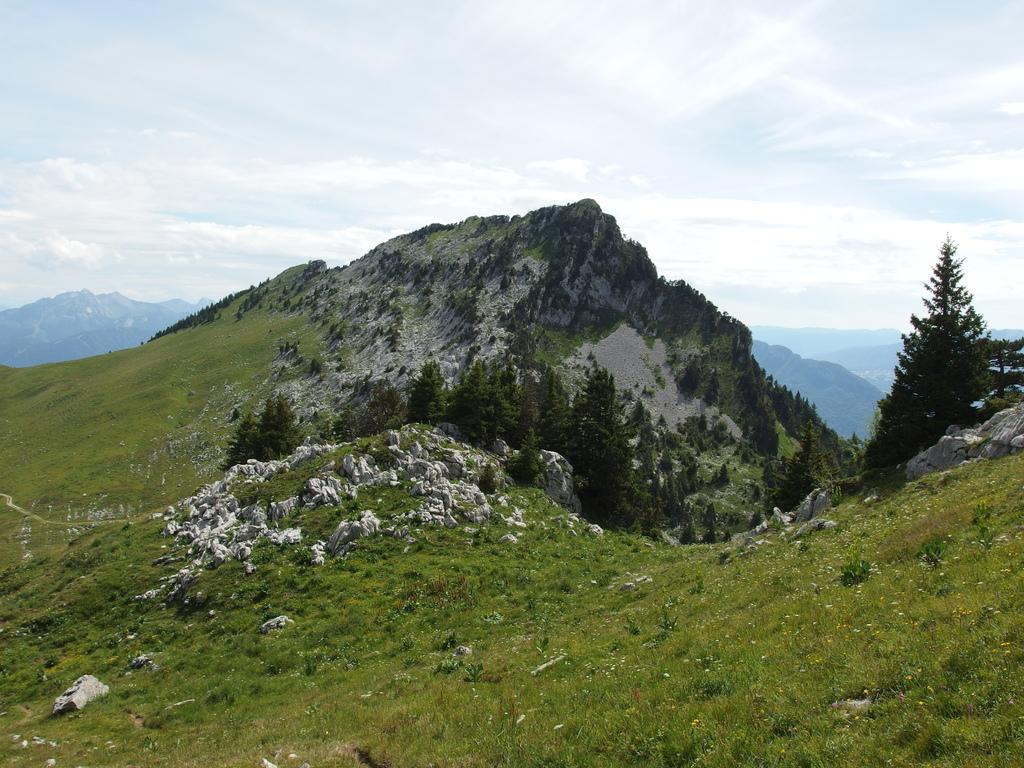What type of vegetation is present on the hill in the image? There are trees and grass on the hill in the image. What can be seen in the background of the image? The background includes hills. What is visible in the sky in the image? The sky is visible in the image, and it is cloudy. What type of education system do the giants have in the image? There are no giants present in the image, so it is not possible to discuss their education system. How do the trees on the hill attack the grass in the image? Trees do not attack grass; they are stationary plants. 